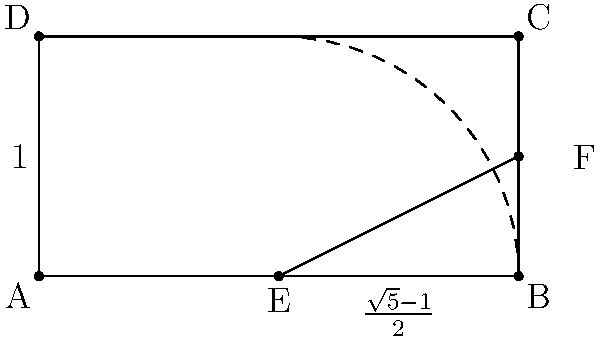In the process of constructing a golden rectangle using only a compass and straightedge, you've drawn a square ABCD with side length 1. What is the length of segment EF that you need to add to the square to complete the golden rectangle? To construct a golden rectangle from a square using only a compass and straightedge, we follow these steps:

1. Start with a square ABCD with side length 1.

2. Find the midpoint E of side AB.

3. Draw an arc from E to C using the compass, which intersects the extension of AB at point F.

4. The length of EF is what we need to add to the square to create the golden rectangle.

To calculate the length of EF:

1. In the right triangle EFC:
   $EC^2 = EF^2 + (1/2)^2$

2. $EC^2 = (5/4)$ (by Pythagorean theorem in triangle ABC)

3. So, $EF^2 + (1/4) = (5/4)$

4. $EF^2 = 1$

5. $EF = \sqrt{1} = 1$

6. The ratio of the longer side to the shorter side in a golden rectangle is $\frac{\sqrt{5}+1}{2}$

7. So, $1 + EF = \frac{\sqrt{5}+1}{2}$

8. $EF = \frac{\sqrt{5}+1}{2} - 1 = \frac{\sqrt{5}-1}{2}$

Therefore, the length of EF that needs to be added to complete the golden rectangle is $\frac{\sqrt{5}-1}{2}$.
Answer: $\frac{\sqrt{5}-1}{2}$ 